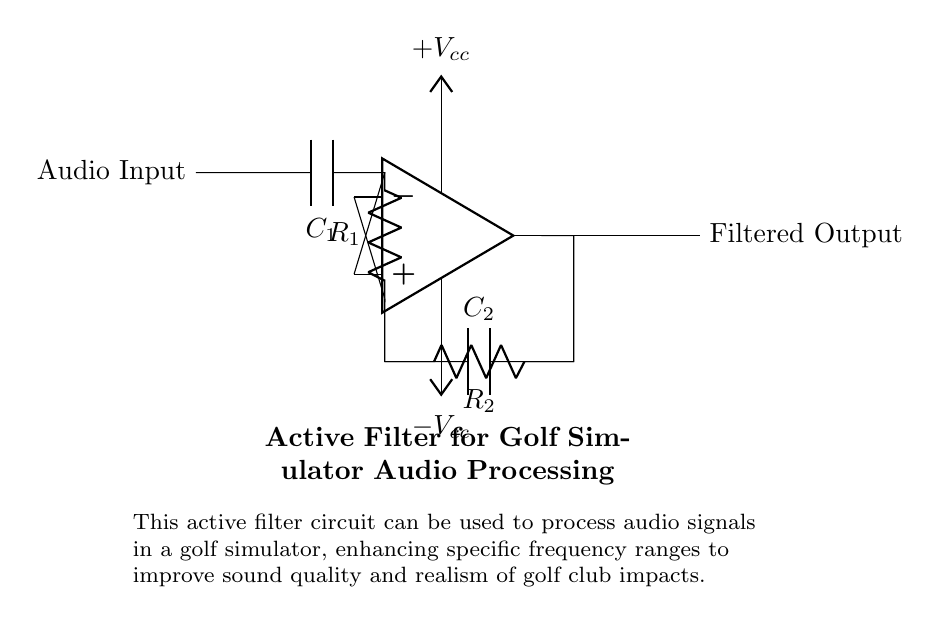What is the type of filter shown? The circuit is an active filter, as indicated by the use of an operational amplifier and associated passive components like resistors and capacitors.
Answer: Active filter What is the function of capacitor C1? Capacitor C1 acts as a coupling capacitor, allowing AC signals (audio input) to pass through while blocking any DC component.
Answer: Coupling capacitor What is the value of resistor R2? The diagram only labels R2 without specifying its resistance value, thus it's not indicated in the circuit.
Answer: Not specified How many voltage supply connections are there? There are two voltage supply connections indicated in the circuit: one for positive voltage and one for negative voltage (Vcc and -Vcc).
Answer: Two What happens if R1 is increased? Increasing R1 will generally lower the cutoff frequency of the filter, allowing lower frequencies to pass through while attenuating higher frequencies.
Answer: Lower cutoff frequency What is the output of this circuit? The output of the circuit is labeled as "Filtered Output," suggesting that the audio signal has been processed to remove undesirable frequency components.
Answer: Filtered Output 